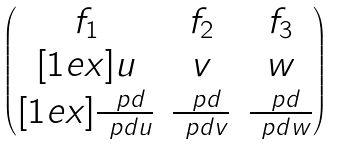Convert formula to latex. <formula><loc_0><loc_0><loc_500><loc_500>\begin{pmatrix} f _ { 1 } & f _ { 2 } & f _ { 3 } \\ [ 1 e x ] u & v & w \\ [ 1 e x ] \frac { \ p d } { \ p d u } & \frac { \ p d } { \ p d v } & \frac { \ p d } { \ p d w } \end{pmatrix}</formula> 